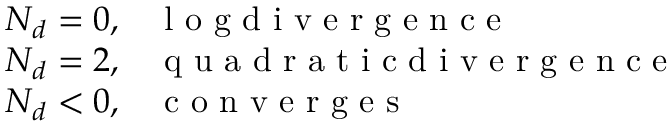<formula> <loc_0><loc_0><loc_500><loc_500>\begin{array} { l l } { N _ { d } = 0 , } & { l o g d i v e r g e n c e } \\ { N _ { d } = 2 , } & { q u a d r a t i c d i v e r g e n c e } \\ { N _ { d } < 0 , } & { c o n v e r g e s } \end{array}</formula> 